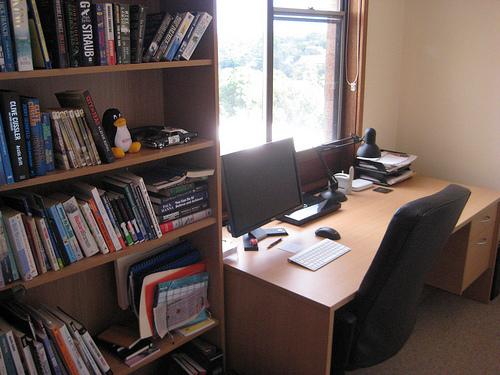Based on the objects on the desk, what type of setting does this image portray? The image portrays an office setting with a desk, computer accessories, and light. Identify the type of animal plushie that is on the shelf. A penguin plushie is on the shelf. In this office setting, what type of toy can be found on a shelf? A toy police car is on a shelf in the office. In the image, describe what the chair next to the desk looks like. The chair next to the desk is a black swiveling office chair. Analyze the interaction between objects on the large brown desk. The white keyboard and black wireless mouse are both on the large brown desk, suggesting a computer workstation setup. What type of office furniture appears to be filled with numerous books? A bookshelf appears to be filled with numerous books. Identify the total number of chairs in the image and describe their colors. There are three chairs in the image: two are black office chairs, and one is a brown chair under the window. What does the sentiment of the image suggest about the space? The sentiment suggests a productive, organized, and efficient office environment. Estimate the image's quality by describing the level of detail offered in the image. The image quality appears to be high, as the image provide detailed information about object positions, sizes, and colors. Examine the image and indicate which object can be used for writing. A pen can be used for writing in the image. If a person is working in this office, what is their most likely posture? Seated on the black swiveling chair, facing the computer monitor Describe the location of the chair and the items placed on it. There is a black office chair beside the desk, and there are books placed on it. Explain the role of each item in the office. Large brown desk for work, black swiveling chair for seating, white keyboard for typing, black wireless mouse for navigating, black lamp for light source, white pencil holder for organizing writing materials, paper organizer for organizing documents, bookshelf with books for reference, and window for view. In this office, what activity could be performed? Working on the computer Write a detailed description of the scene. There is an office with a large brown desk, a black swiveling chair, a white keyboard on a wooden desk, a black wireless mouse on a desk, a black lamp, a white pencil holder, and a paper organizer. There is a bookshelf full of books, a penguin stuff animal on the shelf, and a window in front of the desk. There are various items on the desk, such as a pen, a pencil, and a stack of papers. Based on the items displayed in the office, can you infer whether the person is left-handed or right-handed? Cannot determine from the given information What is the purpose of a white pencil holder in the office? To organize writing materials What color is the office chair and identify its location? The office chair is black and is beside the desk. Is the computer monitor on the desk black or white? Choose the correct option. Answer:  Write a haiku poem based on the office scene. Office in twilight, Describe the light source available in the office. A black desk lamp Create a couplet poem inspired by the objects and scenes in the office. In the quiet office, where ideas take flight, What type of device is the keyboard and the wireless mouse designed for? Computer What type of plushie is on the shelf? Penguin plushie List the items found on the desk in the office. A white keyboard, a black wireless mouse, a black desk lamp, a paper organizer, a pen, a pencil, and a stack of papers. What type of toy is on the shelf next to the penguin plushie? A toy police car Transform this office scene into a short story. In a serene corner of a bustling city, a dedicated worker spends long hours in their office. Surrounded by the comforting presence of a penguin plushie and a toy police car, they diligently work, typing away on their white keyboard, as light from the black lamp illuminates the room. The shelves brimming with knowledge lend a quiet support, with a pen, pencil, and stack of papers waiting to be summoned at any moment. When they need respite, the worker gazes out the window, momentarily lost in the world outside. If each item in the office represents one letter of the alphabet, what word would their arrangement spell? Not possible to spell any word 